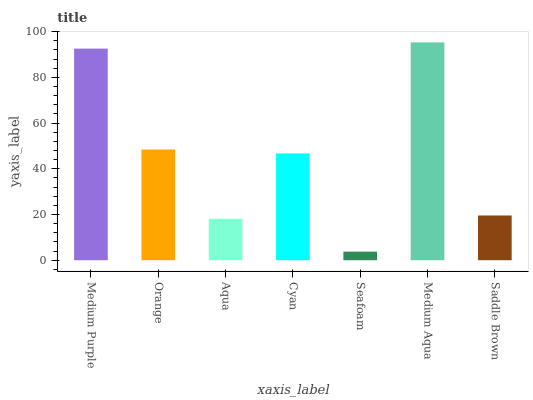Is Seafoam the minimum?
Answer yes or no. Yes. Is Medium Aqua the maximum?
Answer yes or no. Yes. Is Orange the minimum?
Answer yes or no. No. Is Orange the maximum?
Answer yes or no. No. Is Medium Purple greater than Orange?
Answer yes or no. Yes. Is Orange less than Medium Purple?
Answer yes or no. Yes. Is Orange greater than Medium Purple?
Answer yes or no. No. Is Medium Purple less than Orange?
Answer yes or no. No. Is Cyan the high median?
Answer yes or no. Yes. Is Cyan the low median?
Answer yes or no. Yes. Is Orange the high median?
Answer yes or no. No. Is Aqua the low median?
Answer yes or no. No. 